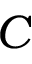Convert formula to latex. <formula><loc_0><loc_0><loc_500><loc_500>C</formula> 